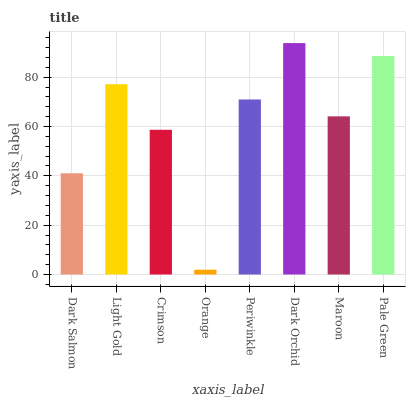Is Orange the minimum?
Answer yes or no. Yes. Is Dark Orchid the maximum?
Answer yes or no. Yes. Is Light Gold the minimum?
Answer yes or no. No. Is Light Gold the maximum?
Answer yes or no. No. Is Light Gold greater than Dark Salmon?
Answer yes or no. Yes. Is Dark Salmon less than Light Gold?
Answer yes or no. Yes. Is Dark Salmon greater than Light Gold?
Answer yes or no. No. Is Light Gold less than Dark Salmon?
Answer yes or no. No. Is Periwinkle the high median?
Answer yes or no. Yes. Is Maroon the low median?
Answer yes or no. Yes. Is Dark Salmon the high median?
Answer yes or no. No. Is Dark Orchid the low median?
Answer yes or no. No. 